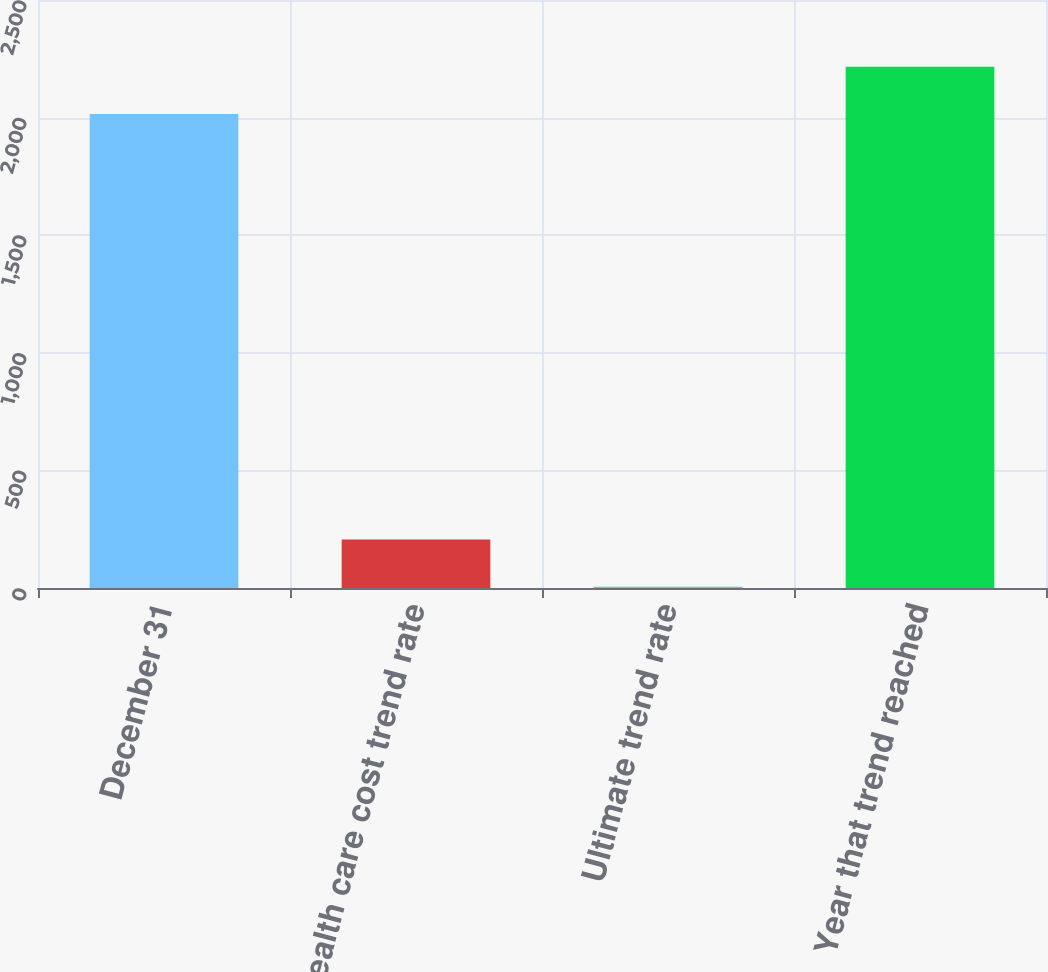<chart> <loc_0><loc_0><loc_500><loc_500><bar_chart><fcel>December 31<fcel>Health care cost trend rate<fcel>Ultimate trend rate<fcel>Year that trend reached<nl><fcel>2015<fcel>206.6<fcel>5<fcel>2216.6<nl></chart> 